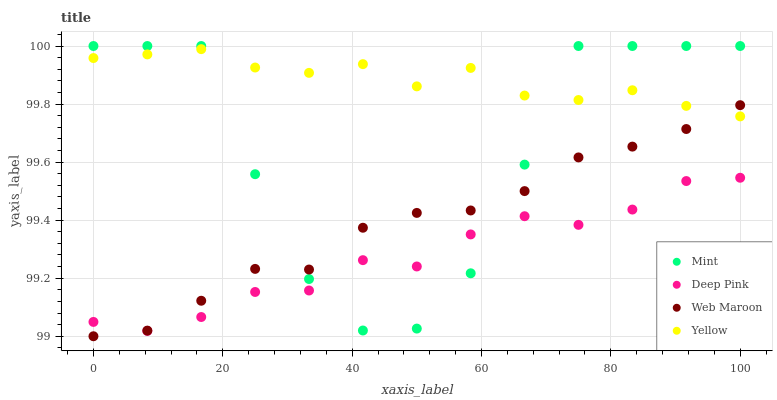Does Deep Pink have the minimum area under the curve?
Answer yes or no. Yes. Does Yellow have the maximum area under the curve?
Answer yes or no. Yes. Does Mint have the minimum area under the curve?
Answer yes or no. No. Does Mint have the maximum area under the curve?
Answer yes or no. No. Is Web Maroon the smoothest?
Answer yes or no. Yes. Is Mint the roughest?
Answer yes or no. Yes. Is Deep Pink the smoothest?
Answer yes or no. No. Is Deep Pink the roughest?
Answer yes or no. No. Does Web Maroon have the lowest value?
Answer yes or no. Yes. Does Deep Pink have the lowest value?
Answer yes or no. No. Does Mint have the highest value?
Answer yes or no. Yes. Does Deep Pink have the highest value?
Answer yes or no. No. Is Deep Pink less than Yellow?
Answer yes or no. Yes. Is Yellow greater than Deep Pink?
Answer yes or no. Yes. Does Mint intersect Web Maroon?
Answer yes or no. Yes. Is Mint less than Web Maroon?
Answer yes or no. No. Is Mint greater than Web Maroon?
Answer yes or no. No. Does Deep Pink intersect Yellow?
Answer yes or no. No. 